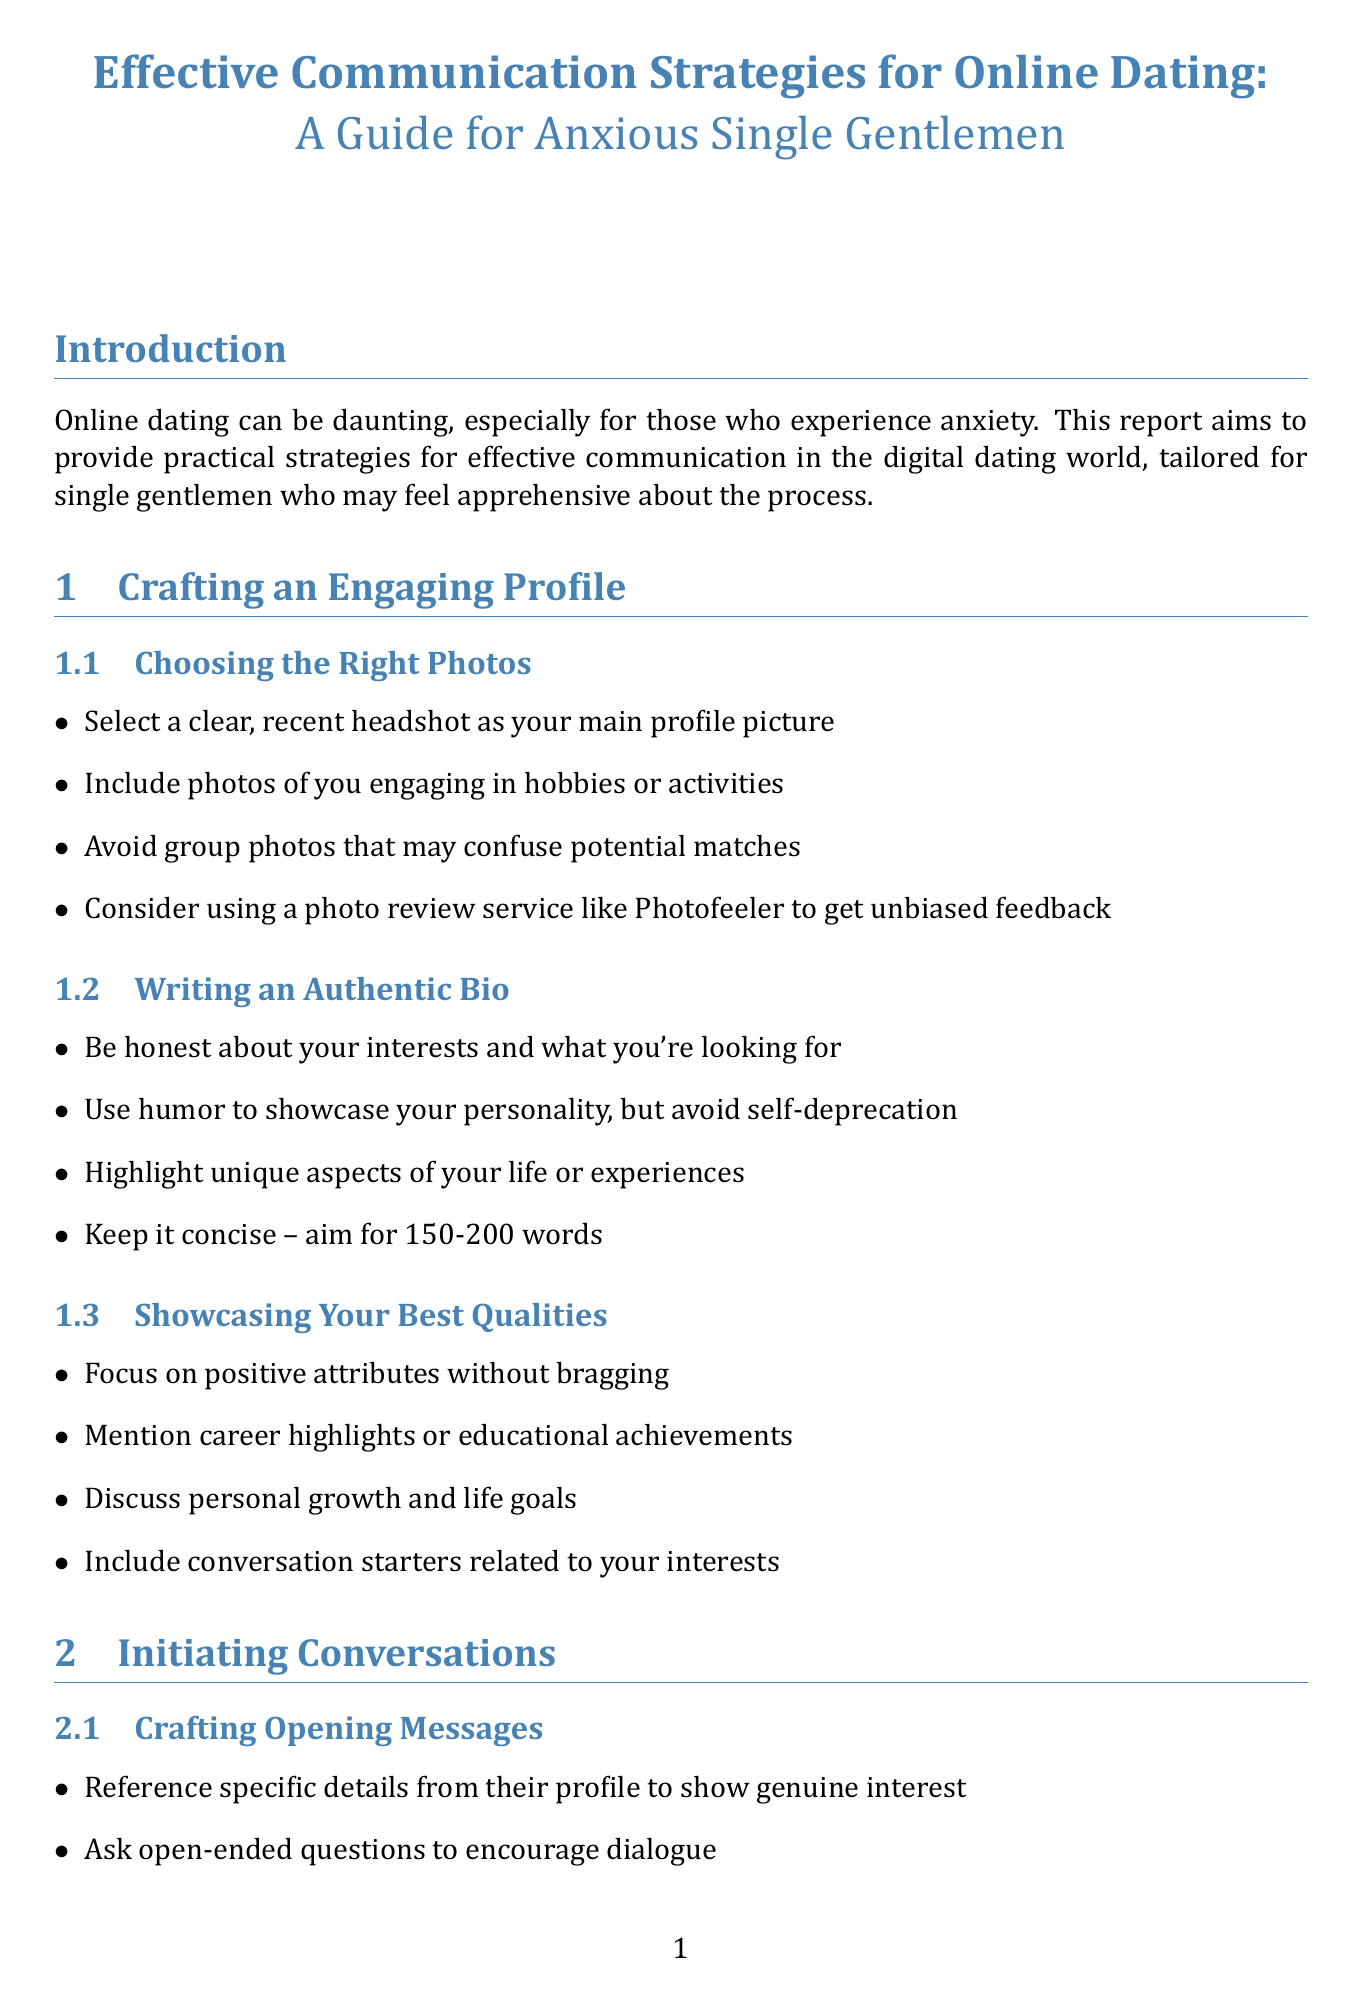What is the title of the report? The title is found in the initial headings of the document.
Answer: Effective Communication Strategies for Online Dating: A Guide for Anxious Single Gentlemen How many subsections are in the "Crafting an Engaging Profile" section? The number of subsections can be counted by reviewing the list under this section.
Answer: 3 What type of message should be avoided when initiating conversations? This is specified in the guidelines for crafting opening messages and relates to tone.
Answer: Generic greetings What is the recommended word count for an authentic bio? The word count is provided as a guideline in the "Writing an Authentic Bio" subsection.
Answer: 150-200 words Which book is suggested for understanding relationship dynamics? This information is listed in the "Helpful Books" section of the document.
Answer: Attached by Amir Levine and Rachel Heller What is a suggested action before sending messages to overcome anxiety? This is found in the tips under the "Overcoming Anxiety When Messaging" subsection.
Answer: Practice deep breathing exercises When should you suggest a meeting with a match? This guideline can be found in the "Timing the Ask" subsection about proposing a date.
Answer: Within 1-2 weeks What communication skill is emphasized for maintaining engaging conversations? This skill is explicitly mentioned in the section about active listening.
Answer: Active listening skills 